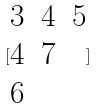<formula> <loc_0><loc_0><loc_500><loc_500>[ \begin{matrix} 3 & 4 & 5 \\ 4 & 7 \\ 6 \end{matrix} ]</formula> 